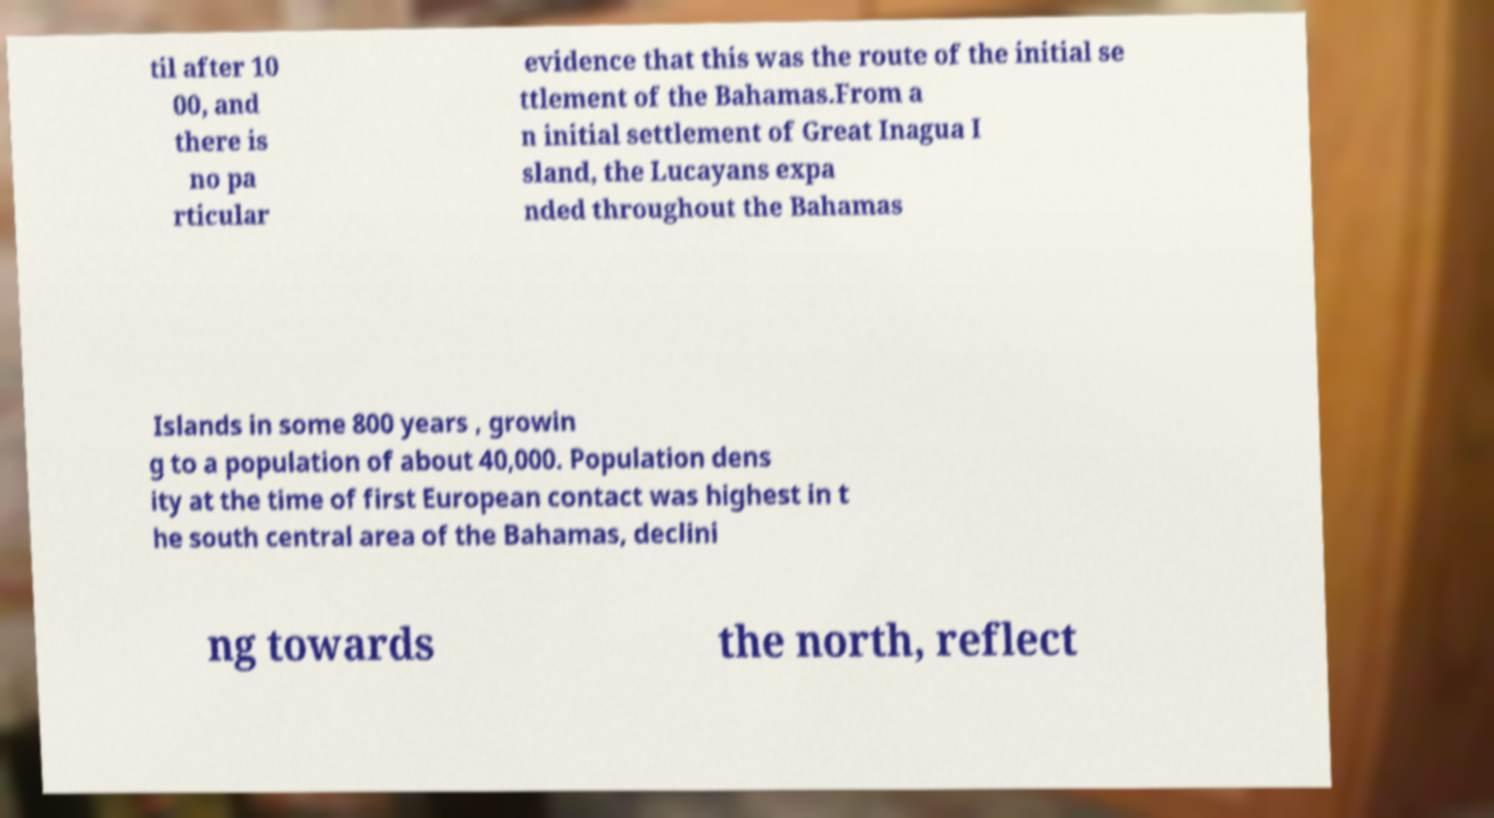For documentation purposes, I need the text within this image transcribed. Could you provide that? til after 10 00, and there is no pa rticular evidence that this was the route of the initial se ttlement of the Bahamas.From a n initial settlement of Great Inagua I sland, the Lucayans expa nded throughout the Bahamas Islands in some 800 years , growin g to a population of about 40,000. Population dens ity at the time of first European contact was highest in t he south central area of the Bahamas, declini ng towards the north, reflect 